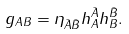Convert formula to latex. <formula><loc_0><loc_0><loc_500><loc_500>g _ { A B } = \eta _ { \bar { A } \bar { B } } h ^ { \bar { A } } _ { A } h ^ { \bar { B } } _ { B } .</formula> 